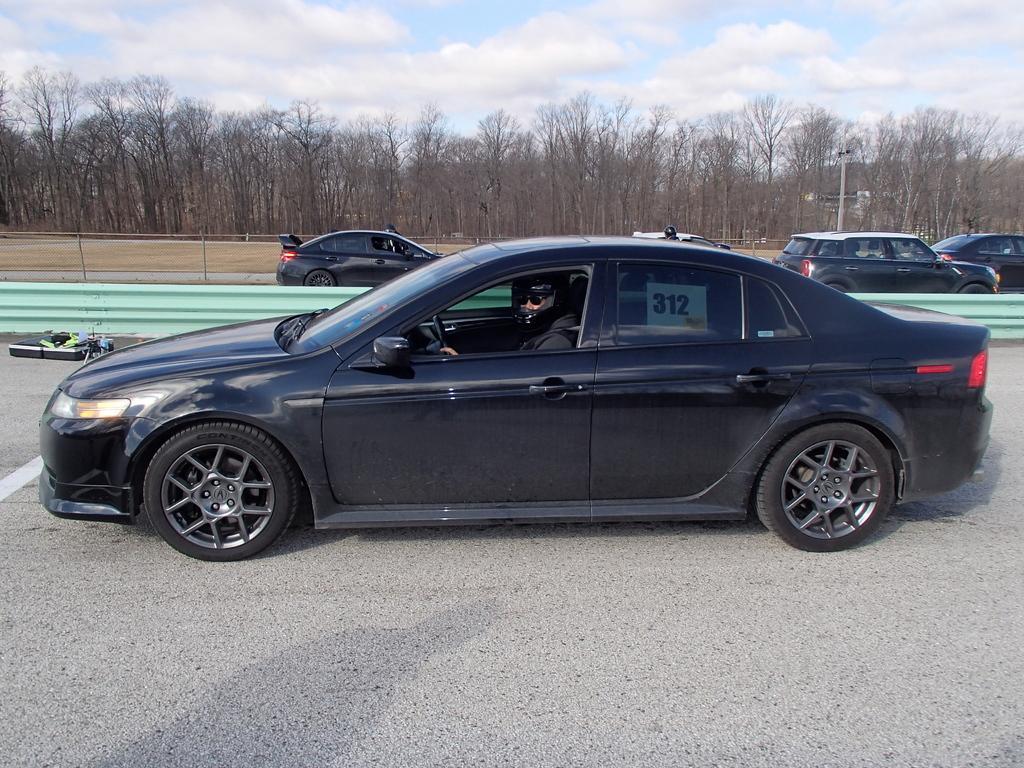Please provide a concise description of this image. There is a person sitting inside a car and wore helmet and we can see cars on the road and fence. In the background we can see pole, trees and sky with clouds. 